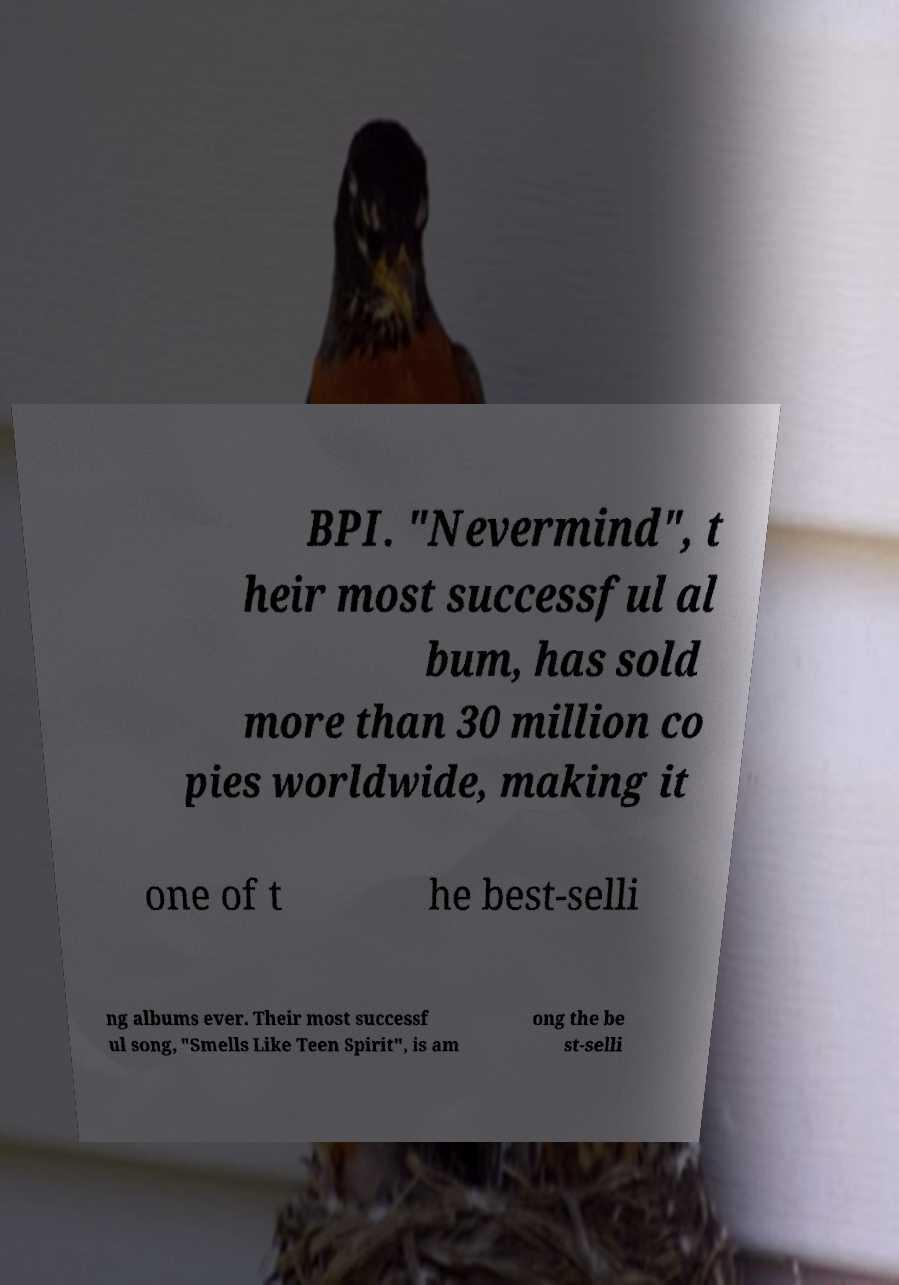Can you accurately transcribe the text from the provided image for me? BPI. "Nevermind", t heir most successful al bum, has sold more than 30 million co pies worldwide, making it one of t he best-selli ng albums ever. Their most successf ul song, "Smells Like Teen Spirit", is am ong the be st-selli 